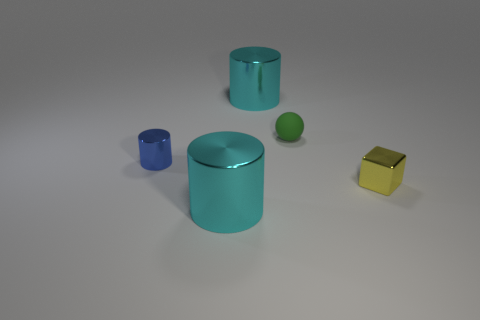Subtract all tiny blue metal cylinders. How many cylinders are left? 2 Add 1 small blue rubber balls. How many objects exist? 6 Subtract all blue cylinders. How many cylinders are left? 2 Subtract all cubes. How many objects are left? 4 Subtract 1 cubes. How many cubes are left? 0 Subtract all gray spheres. Subtract all green cubes. How many spheres are left? 1 Subtract all yellow spheres. How many cyan cylinders are left? 2 Subtract all green spheres. Subtract all tiny green rubber things. How many objects are left? 3 Add 4 yellow metallic blocks. How many yellow metallic blocks are left? 5 Add 2 large cyan metallic cylinders. How many large cyan metallic cylinders exist? 4 